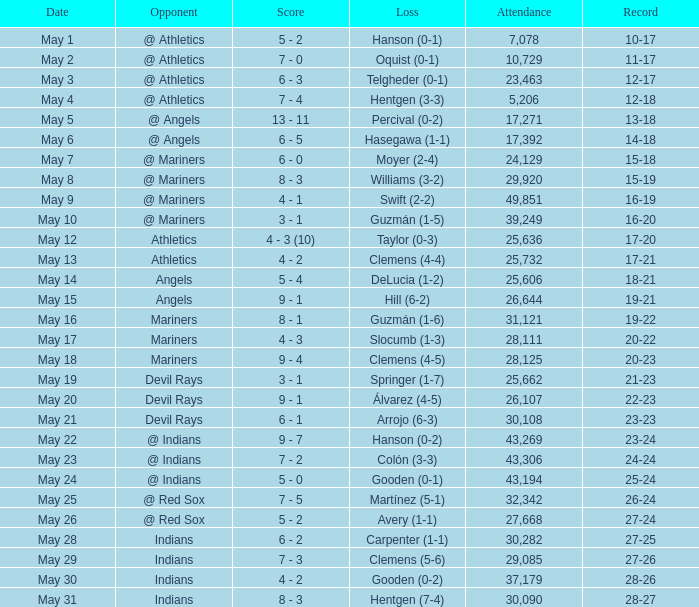What is the record for May 31? 28-27. 